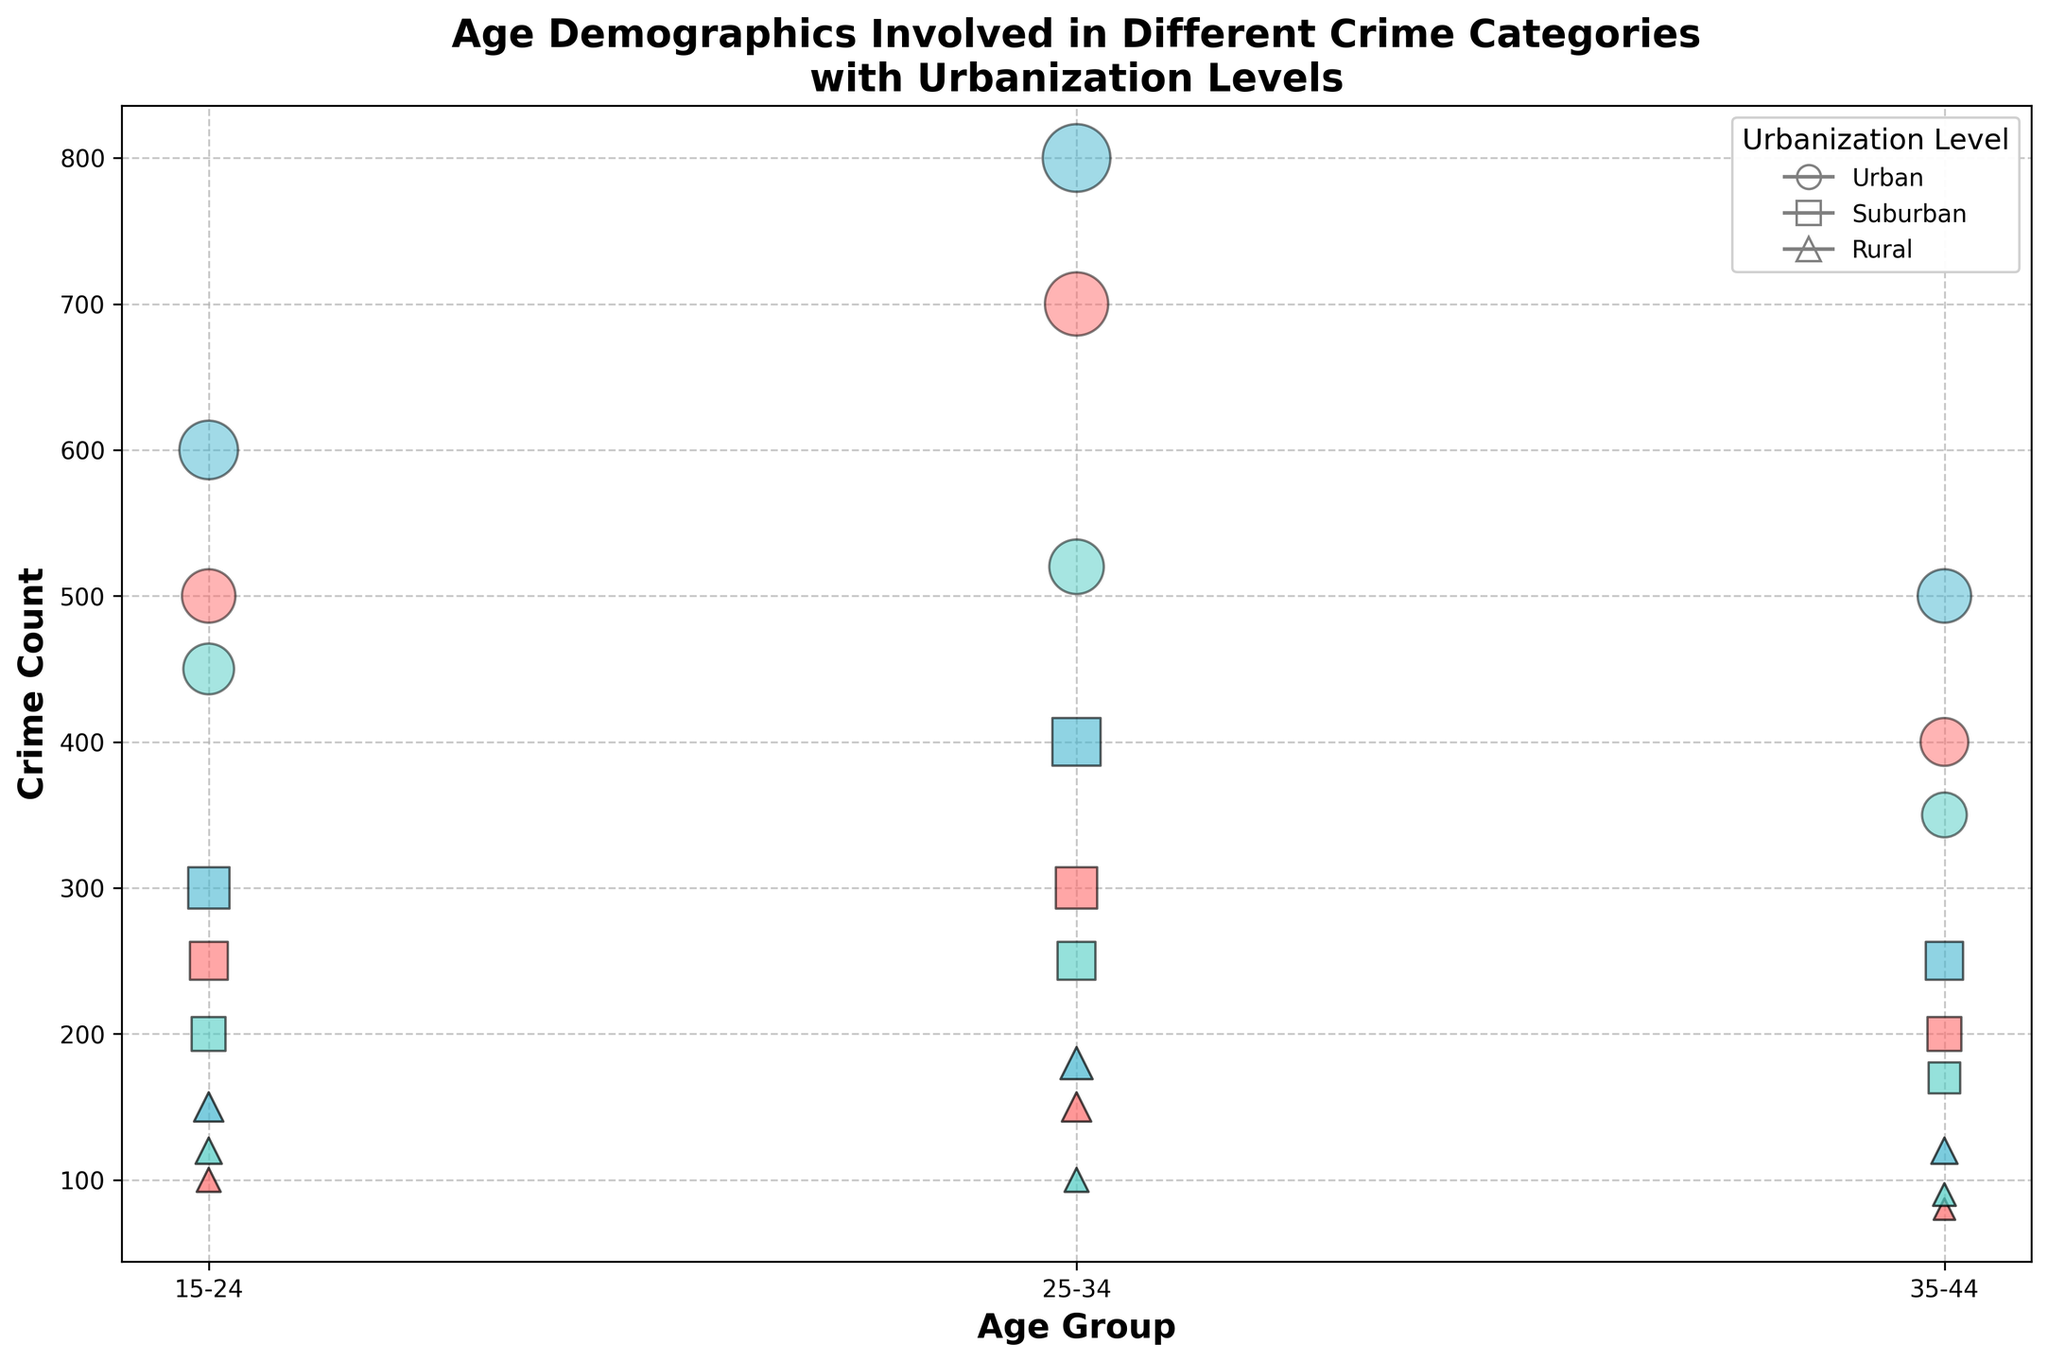How many crime categories are displayed in the figure? The legend for crime categories displays three different markers, one for each crime category.
Answer: 3 Which age group has the highest crime count for drug offenses in suburban areas? The scatter plot shows the largest bubble size corresponding to drug offenses in suburban areas for the age group 25-34.
Answer: 25-34 What is the total number of urban crime counts for the age group 15-24? To get the total, sum the urban crime counts for 15-24 across all crime categories: Theft (500), Assault (450), and Drug Offenses (600). The calculation is 500 + 450 + 600.
Answer: 1550 Which urbanization level has the least total crime count for the crime category "Assault"? Compare the bubble sizes across urbanization levels within the Assault category. The smallest bubbles appear in rural areas for each age group involved. Sum the rural Assault crime counts: 15-24 (120), 25-34 (100), 35-44 (90). The calculation is 120 + 100 + 90.
Answer: Rural For the crime category "Theft," which age group shows a consistent decrease in crime count from urban to rural areas? Analyze the bubble sizes for Theft in all age groups: 
- 15-24: Urban (500), Suburban (250), Rural (100). 
- 25-34: Urban (700), Suburban (300), Rural (150). 
- 35-44: Urban (400), Suburban (200), Rural (80). 
Only the 35-44 age group shows a consistent decrease.
Answer: 35-44 What markers are used to represent suburban areas, and what color are they for Assault crimes? Identify the shape of the markers for suburban areas (squares) and the color for Assault (aqua/greenish).
Answer: Squares, Aqua/Green Which age group and crime category combination has the highest count in rural areas? Identify the highest bubble size for rural areas across all crime categories and age groups. Drug Offenses for 25-34 with 180.
Answer: 25-34, Drug Offenses What is the total crime count for all drug offenses in urban areas across all age groups? Sum the urban crime counts for Drug Offenses in all age groups: 15-24 (600), 25-34 (800), 35-44 (500). The calculation is 600 + 800 + 500.
Answer: 1900 Compare the transparency levels of bubbles for the 35-44 age group across all crime categories. Are they the same? The explanation involves recognizing the transparency levels in the figure and comparing them for the 35-44 age group across crimes. All transparency levels are set to the same value (0.5).
Answer: Yes 